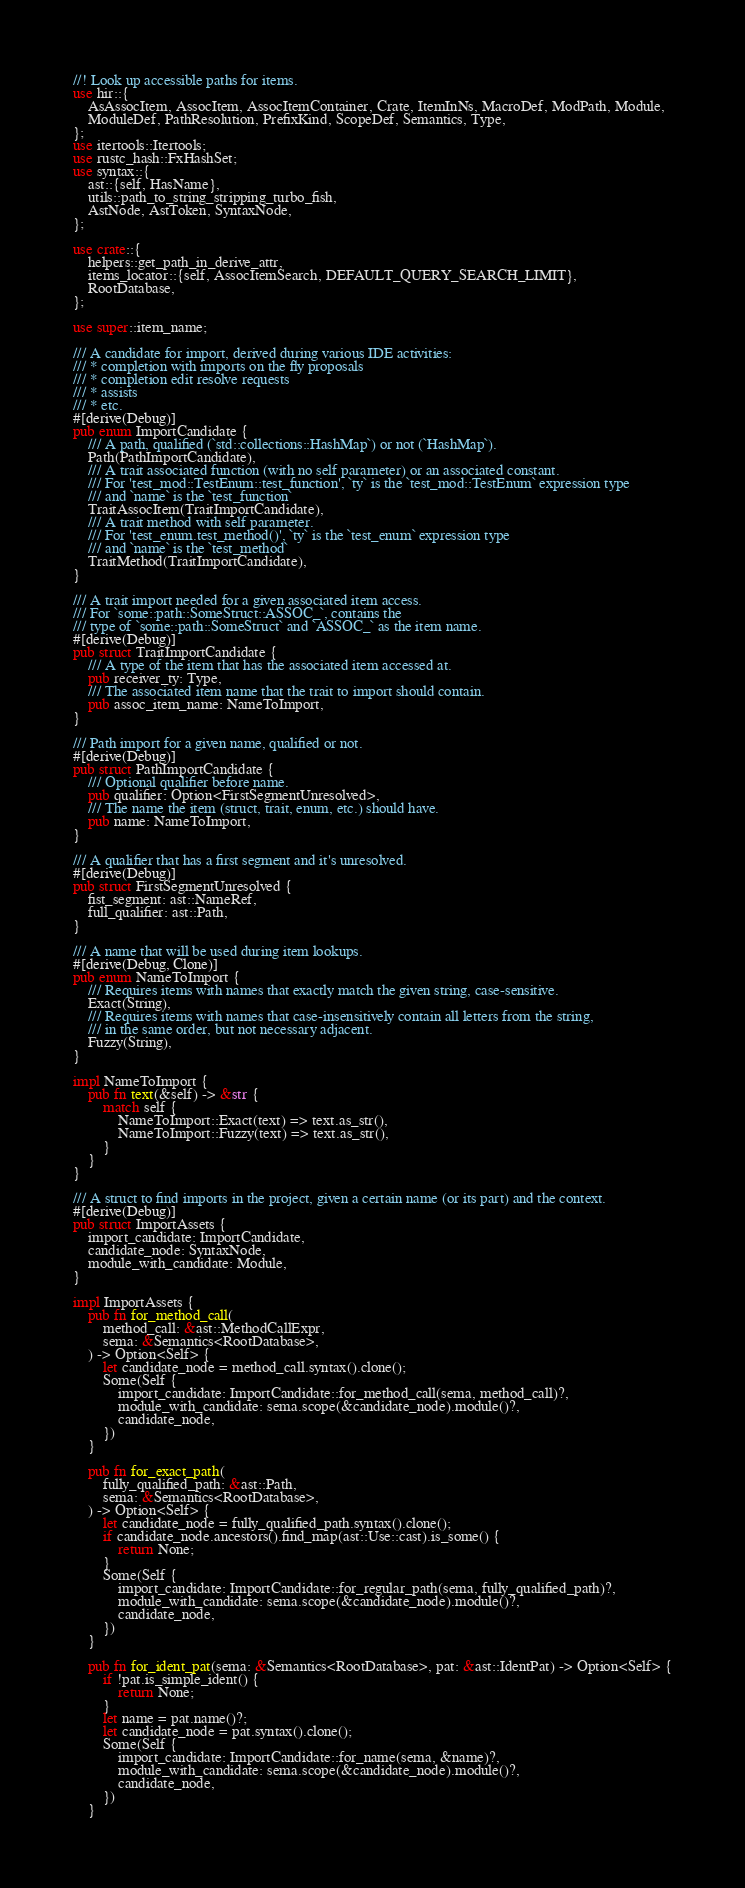Convert code to text. <code><loc_0><loc_0><loc_500><loc_500><_Rust_>//! Look up accessible paths for items.
use hir::{
    AsAssocItem, AssocItem, AssocItemContainer, Crate, ItemInNs, MacroDef, ModPath, Module,
    ModuleDef, PathResolution, PrefixKind, ScopeDef, Semantics, Type,
};
use itertools::Itertools;
use rustc_hash::FxHashSet;
use syntax::{
    ast::{self, HasName},
    utils::path_to_string_stripping_turbo_fish,
    AstNode, AstToken, SyntaxNode,
};

use crate::{
    helpers::get_path_in_derive_attr,
    items_locator::{self, AssocItemSearch, DEFAULT_QUERY_SEARCH_LIMIT},
    RootDatabase,
};

use super::item_name;

/// A candidate for import, derived during various IDE activities:
/// * completion with imports on the fly proposals
/// * completion edit resolve requests
/// * assists
/// * etc.
#[derive(Debug)]
pub enum ImportCandidate {
    /// A path, qualified (`std::collections::HashMap`) or not (`HashMap`).
    Path(PathImportCandidate),
    /// A trait associated function (with no self parameter) or an associated constant.
    /// For 'test_mod::TestEnum::test_function', `ty` is the `test_mod::TestEnum` expression type
    /// and `name` is the `test_function`
    TraitAssocItem(TraitImportCandidate),
    /// A trait method with self parameter.
    /// For 'test_enum.test_method()', `ty` is the `test_enum` expression type
    /// and `name` is the `test_method`
    TraitMethod(TraitImportCandidate),
}

/// A trait import needed for a given associated item access.
/// For `some::path::SomeStruct::ASSOC_`, contains the
/// type of `some::path::SomeStruct` and `ASSOC_` as the item name.
#[derive(Debug)]
pub struct TraitImportCandidate {
    /// A type of the item that has the associated item accessed at.
    pub receiver_ty: Type,
    /// The associated item name that the trait to import should contain.
    pub assoc_item_name: NameToImport,
}

/// Path import for a given name, qualified or not.
#[derive(Debug)]
pub struct PathImportCandidate {
    /// Optional qualifier before name.
    pub qualifier: Option<FirstSegmentUnresolved>,
    /// The name the item (struct, trait, enum, etc.) should have.
    pub name: NameToImport,
}

/// A qualifier that has a first segment and it's unresolved.
#[derive(Debug)]
pub struct FirstSegmentUnresolved {
    fist_segment: ast::NameRef,
    full_qualifier: ast::Path,
}

/// A name that will be used during item lookups.
#[derive(Debug, Clone)]
pub enum NameToImport {
    /// Requires items with names that exactly match the given string, case-sensitive.
    Exact(String),
    /// Requires items with names that case-insensitively contain all letters from the string,
    /// in the same order, but not necessary adjacent.
    Fuzzy(String),
}

impl NameToImport {
    pub fn text(&self) -> &str {
        match self {
            NameToImport::Exact(text) => text.as_str(),
            NameToImport::Fuzzy(text) => text.as_str(),
        }
    }
}

/// A struct to find imports in the project, given a certain name (or its part) and the context.
#[derive(Debug)]
pub struct ImportAssets {
    import_candidate: ImportCandidate,
    candidate_node: SyntaxNode,
    module_with_candidate: Module,
}

impl ImportAssets {
    pub fn for_method_call(
        method_call: &ast::MethodCallExpr,
        sema: &Semantics<RootDatabase>,
    ) -> Option<Self> {
        let candidate_node = method_call.syntax().clone();
        Some(Self {
            import_candidate: ImportCandidate::for_method_call(sema, method_call)?,
            module_with_candidate: sema.scope(&candidate_node).module()?,
            candidate_node,
        })
    }

    pub fn for_exact_path(
        fully_qualified_path: &ast::Path,
        sema: &Semantics<RootDatabase>,
    ) -> Option<Self> {
        let candidate_node = fully_qualified_path.syntax().clone();
        if candidate_node.ancestors().find_map(ast::Use::cast).is_some() {
            return None;
        }
        Some(Self {
            import_candidate: ImportCandidate::for_regular_path(sema, fully_qualified_path)?,
            module_with_candidate: sema.scope(&candidate_node).module()?,
            candidate_node,
        })
    }

    pub fn for_ident_pat(sema: &Semantics<RootDatabase>, pat: &ast::IdentPat) -> Option<Self> {
        if !pat.is_simple_ident() {
            return None;
        }
        let name = pat.name()?;
        let candidate_node = pat.syntax().clone();
        Some(Self {
            import_candidate: ImportCandidate::for_name(sema, &name)?,
            module_with_candidate: sema.scope(&candidate_node).module()?,
            candidate_node,
        })
    }
</code> 